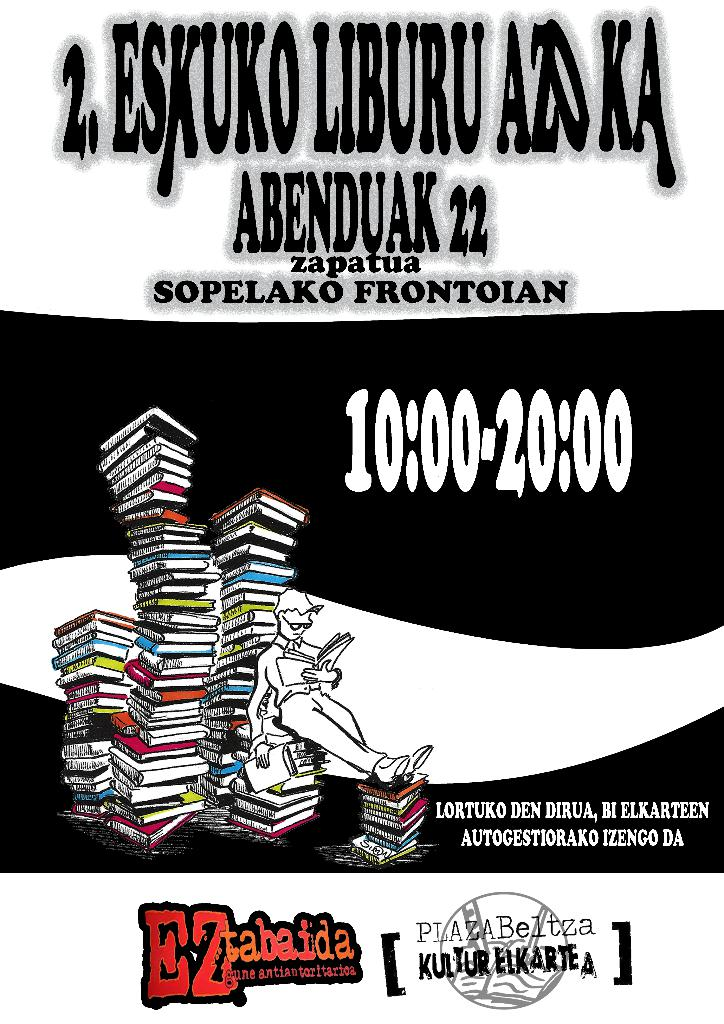What might be the significance of using stacked books in the image? The stacked books symbolize a wealth of knowledge and the enrichment that comes from reading. The height of the stack may suggest the vast amount and diversity of literature available and emphasizes the event's focus on books and learning. How could the setting and date of the event add to its appeal? The event's scheduling during the holiday season on December 22, and its location at Sopelako Frontonian, a likely culturally significant venue, make it an attractive outing for families and literature enthusiasts looking to enrich their holiday experience. 